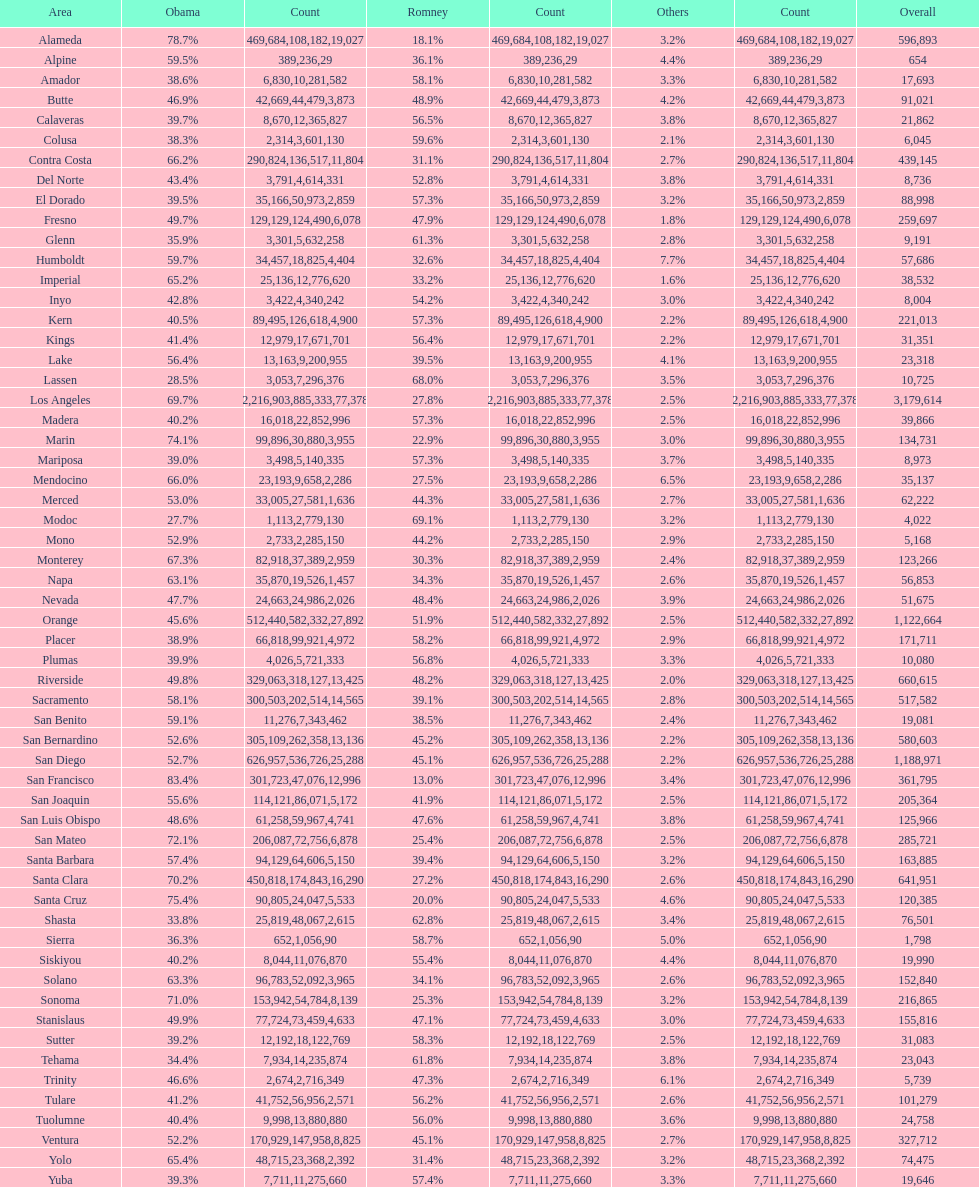Help me parse the entirety of this table. {'header': ['Area', 'Obama', 'Count', 'Romney', 'Count', 'Others', 'Count', 'Overall'], 'rows': [['Alameda', '78.7%', '469,684', '18.1%', '108,182', '3.2%', '19,027', '596,893'], ['Alpine', '59.5%', '389', '36.1%', '236', '4.4%', '29', '654'], ['Amador', '38.6%', '6,830', '58.1%', '10,281', '3.3%', '582', '17,693'], ['Butte', '46.9%', '42,669', '48.9%', '44,479', '4.2%', '3,873', '91,021'], ['Calaveras', '39.7%', '8,670', '56.5%', '12,365', '3.8%', '827', '21,862'], ['Colusa', '38.3%', '2,314', '59.6%', '3,601', '2.1%', '130', '6,045'], ['Contra Costa', '66.2%', '290,824', '31.1%', '136,517', '2.7%', '11,804', '439,145'], ['Del Norte', '43.4%', '3,791', '52.8%', '4,614', '3.8%', '331', '8,736'], ['El Dorado', '39.5%', '35,166', '57.3%', '50,973', '3.2%', '2,859', '88,998'], ['Fresno', '49.7%', '129,129', '47.9%', '124,490', '1.8%', '6,078', '259,697'], ['Glenn', '35.9%', '3,301', '61.3%', '5,632', '2.8%', '258', '9,191'], ['Humboldt', '59.7%', '34,457', '32.6%', '18,825', '7.7%', '4,404', '57,686'], ['Imperial', '65.2%', '25,136', '33.2%', '12,776', '1.6%', '620', '38,532'], ['Inyo', '42.8%', '3,422', '54.2%', '4,340', '3.0%', '242', '8,004'], ['Kern', '40.5%', '89,495', '57.3%', '126,618', '2.2%', '4,900', '221,013'], ['Kings', '41.4%', '12,979', '56.4%', '17,671', '2.2%', '701', '31,351'], ['Lake', '56.4%', '13,163', '39.5%', '9,200', '4.1%', '955', '23,318'], ['Lassen', '28.5%', '3,053', '68.0%', '7,296', '3.5%', '376', '10,725'], ['Los Angeles', '69.7%', '2,216,903', '27.8%', '885,333', '2.5%', '77,378', '3,179,614'], ['Madera', '40.2%', '16,018', '57.3%', '22,852', '2.5%', '996', '39,866'], ['Marin', '74.1%', '99,896', '22.9%', '30,880', '3.0%', '3,955', '134,731'], ['Mariposa', '39.0%', '3,498', '57.3%', '5,140', '3.7%', '335', '8,973'], ['Mendocino', '66.0%', '23,193', '27.5%', '9,658', '6.5%', '2,286', '35,137'], ['Merced', '53.0%', '33,005', '44.3%', '27,581', '2.7%', '1,636', '62,222'], ['Modoc', '27.7%', '1,113', '69.1%', '2,779', '3.2%', '130', '4,022'], ['Mono', '52.9%', '2,733', '44.2%', '2,285', '2.9%', '150', '5,168'], ['Monterey', '67.3%', '82,918', '30.3%', '37,389', '2.4%', '2,959', '123,266'], ['Napa', '63.1%', '35,870', '34.3%', '19,526', '2.6%', '1,457', '56,853'], ['Nevada', '47.7%', '24,663', '48.4%', '24,986', '3.9%', '2,026', '51,675'], ['Orange', '45.6%', '512,440', '51.9%', '582,332', '2.5%', '27,892', '1,122,664'], ['Placer', '38.9%', '66,818', '58.2%', '99,921', '2.9%', '4,972', '171,711'], ['Plumas', '39.9%', '4,026', '56.8%', '5,721', '3.3%', '333', '10,080'], ['Riverside', '49.8%', '329,063', '48.2%', '318,127', '2.0%', '13,425', '660,615'], ['Sacramento', '58.1%', '300,503', '39.1%', '202,514', '2.8%', '14,565', '517,582'], ['San Benito', '59.1%', '11,276', '38.5%', '7,343', '2.4%', '462', '19,081'], ['San Bernardino', '52.6%', '305,109', '45.2%', '262,358', '2.2%', '13,136', '580,603'], ['San Diego', '52.7%', '626,957', '45.1%', '536,726', '2.2%', '25,288', '1,188,971'], ['San Francisco', '83.4%', '301,723', '13.0%', '47,076', '3.4%', '12,996', '361,795'], ['San Joaquin', '55.6%', '114,121', '41.9%', '86,071', '2.5%', '5,172', '205,364'], ['San Luis Obispo', '48.6%', '61,258', '47.6%', '59,967', '3.8%', '4,741', '125,966'], ['San Mateo', '72.1%', '206,087', '25.4%', '72,756', '2.5%', '6,878', '285,721'], ['Santa Barbara', '57.4%', '94,129', '39.4%', '64,606', '3.2%', '5,150', '163,885'], ['Santa Clara', '70.2%', '450,818', '27.2%', '174,843', '2.6%', '16,290', '641,951'], ['Santa Cruz', '75.4%', '90,805', '20.0%', '24,047', '4.6%', '5,533', '120,385'], ['Shasta', '33.8%', '25,819', '62.8%', '48,067', '3.4%', '2,615', '76,501'], ['Sierra', '36.3%', '652', '58.7%', '1,056', '5.0%', '90', '1,798'], ['Siskiyou', '40.2%', '8,044', '55.4%', '11,076', '4.4%', '870', '19,990'], ['Solano', '63.3%', '96,783', '34.1%', '52,092', '2.6%', '3,965', '152,840'], ['Sonoma', '71.0%', '153,942', '25.3%', '54,784', '3.2%', '8,139', '216,865'], ['Stanislaus', '49.9%', '77,724', '47.1%', '73,459', '3.0%', '4,633', '155,816'], ['Sutter', '39.2%', '12,192', '58.3%', '18,122', '2.5%', '769', '31,083'], ['Tehama', '34.4%', '7,934', '61.8%', '14,235', '3.8%', '874', '23,043'], ['Trinity', '46.6%', '2,674', '47.3%', '2,716', '6.1%', '349', '5,739'], ['Tulare', '41.2%', '41,752', '56.2%', '56,956', '2.6%', '2,571', '101,279'], ['Tuolumne', '40.4%', '9,998', '56.0%', '13,880', '3.6%', '880', '24,758'], ['Ventura', '52.2%', '170,929', '45.1%', '147,958', '2.7%', '8,825', '327,712'], ['Yolo', '65.4%', '48,715', '31.4%', '23,368', '3.2%', '2,392', '74,475'], ['Yuba', '39.3%', '7,711', '57.4%', '11,275', '3.3%', '660', '19,646']]} Which county had the lower percentage votes for obama: amador, humboldt, or lake? Amador. 